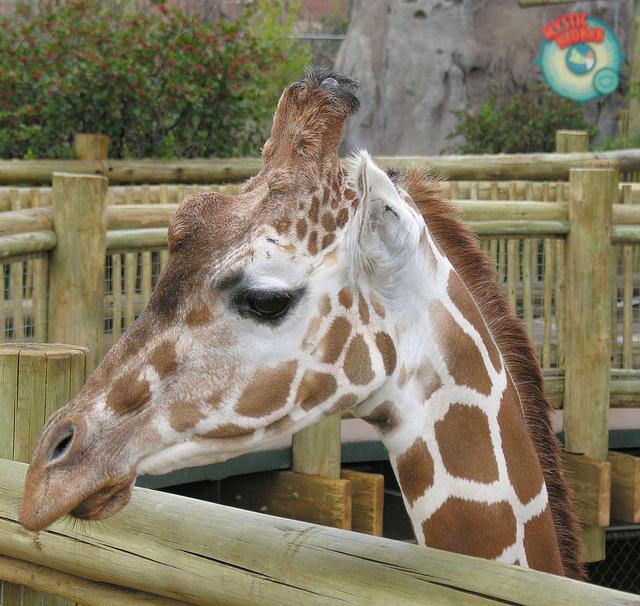Is this animal in the wild?
Concise answer only. No. What is the fence made of?
Be succinct. Wood. What animal is this?
Short answer required. Giraffe. 